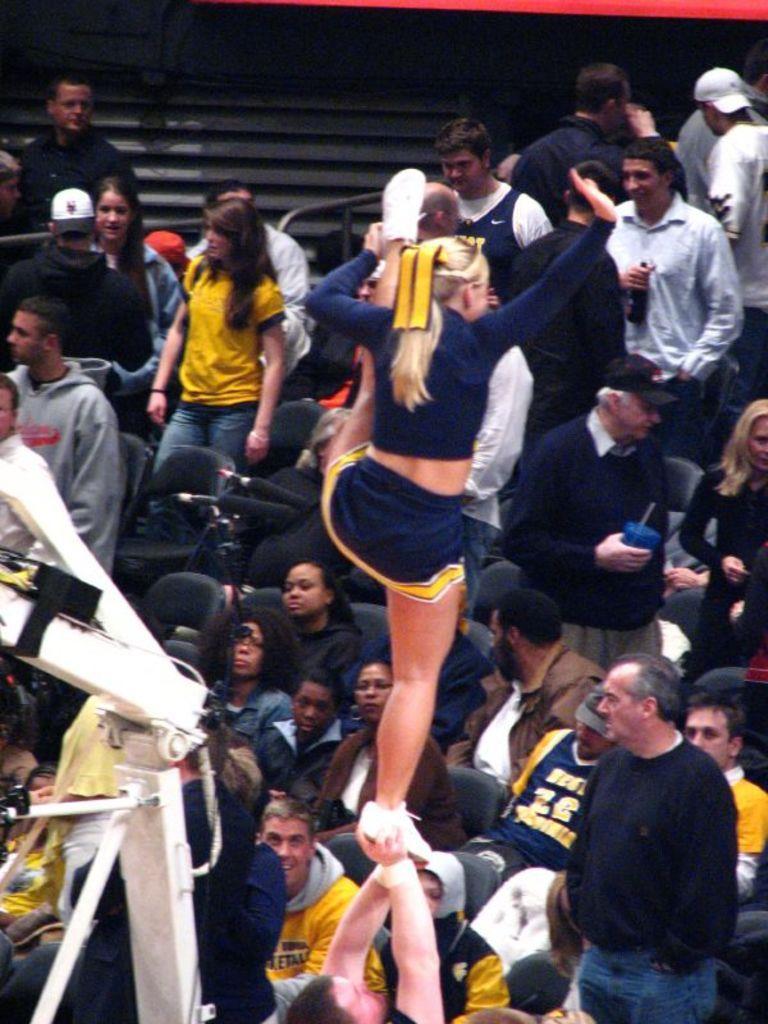Describe this image in one or two sentences. In this picture I can see a woman standing on the hands of another person. I can see group of people, chairs and some other objects. 